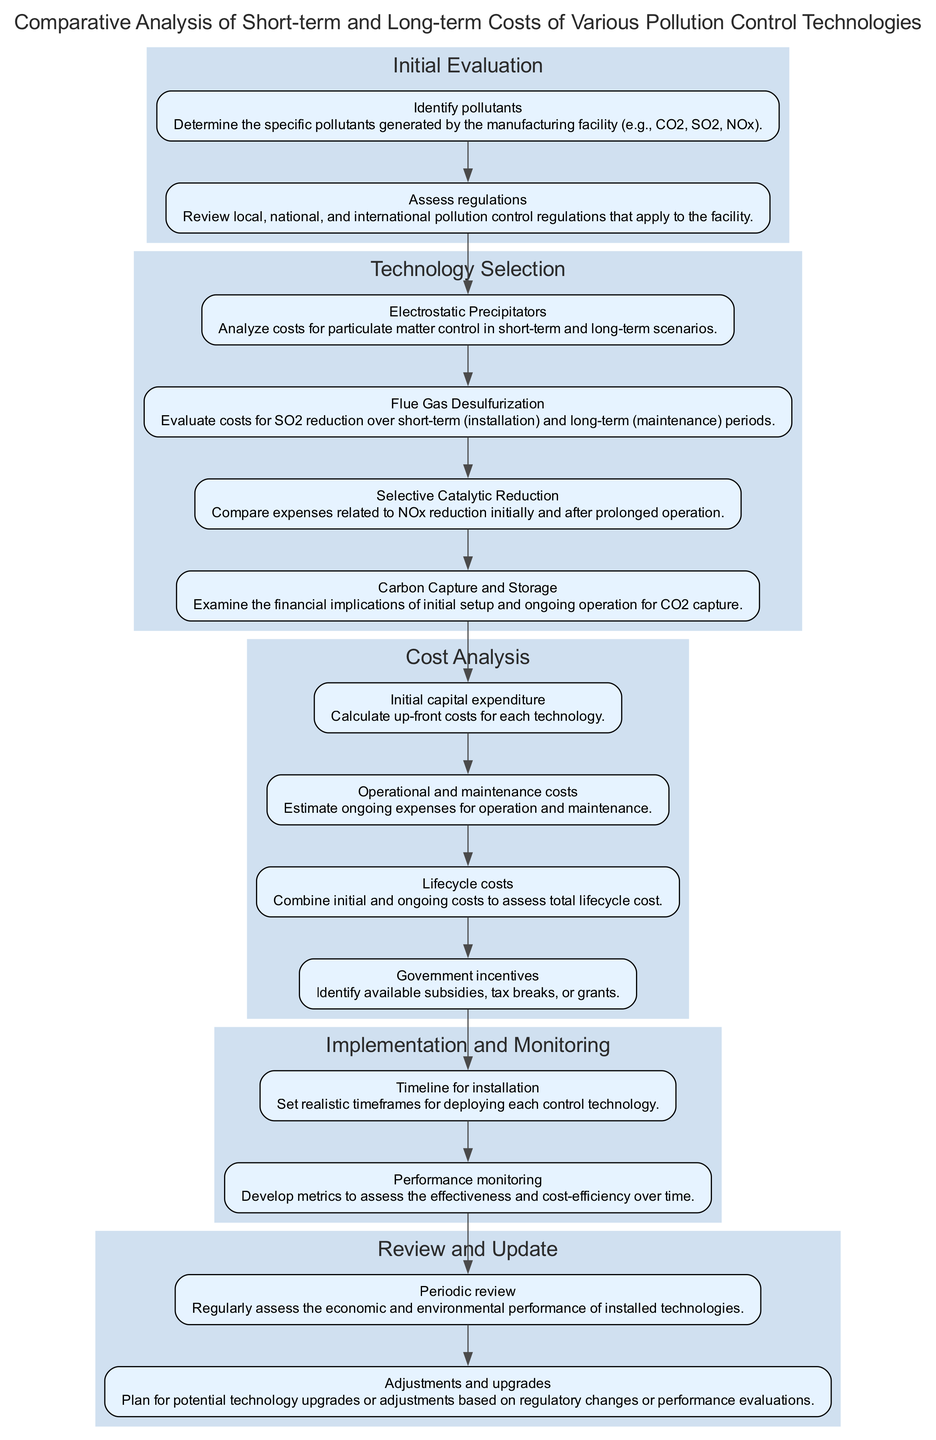What is the first phase in the pathway? The first phase of the pathway is shown at the top of the diagram, labeled as "Initial Evaluation." This is the first grouping of components in the flow.
Answer: Initial Evaluation How many components are there in the Technology Selection phase? By counting the nodes within the Technology Selection phase, we see there are a total of four components that focus on different pollution control technologies.
Answer: 4 Which component assesses regulations? Looking at the components listed under the Initial Evaluation phase, the component titled "Assess regulations" clearly identifies the task of reviewing applicable pollution regulations.
Answer: Assess regulations What are the two main types of costs analyzed in the Cost Analysis phase? In the Cost Analysis phase, two critical components are highlighted: "Initial capital expenditure" and "Operational and maintenance costs," indicating the focus on both upfront and ongoing costs.
Answer: Initial capital expenditure, Operational and maintenance costs What action occurs after the Performance monitoring component? The structure of the diagram indicates that "Periodic review" follows directly from the "Performance monitoring" component, showing this action is necessary to assess the technologies' efficiency.
Answer: Periodic review How does the Implementation and Monitoring phase connect to the Review and Update phase? The connection between these two phases is made through the flow of actions depicted in the diagram, where the performance monitoring feeds directly into the periodic review and the potential for adjustments.
Answer: Performance monitoring to Periodic review What is assessed in the Lifecycle costs component? This component focuses on evaluating the total costs over the lifespan of the technology, which combines both initial and ongoing expenses, reflecting the comprehensive cost analysis required for decision-making.
Answer: Total costs over lifespan Which component focuses on government support? Within the Cost Analysis phase, the component labeled "Government incentives" is specifically tasked with identifying financial support mechanisms like subsidies that can benefit pollution control initiatives.
Answer: Government incentives 